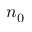Convert formula to latex. <formula><loc_0><loc_0><loc_500><loc_500>n _ { 0 }</formula> 